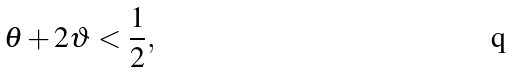<formula> <loc_0><loc_0><loc_500><loc_500>\theta + 2 \vartheta < \frac { 1 } { 2 } ,</formula> 